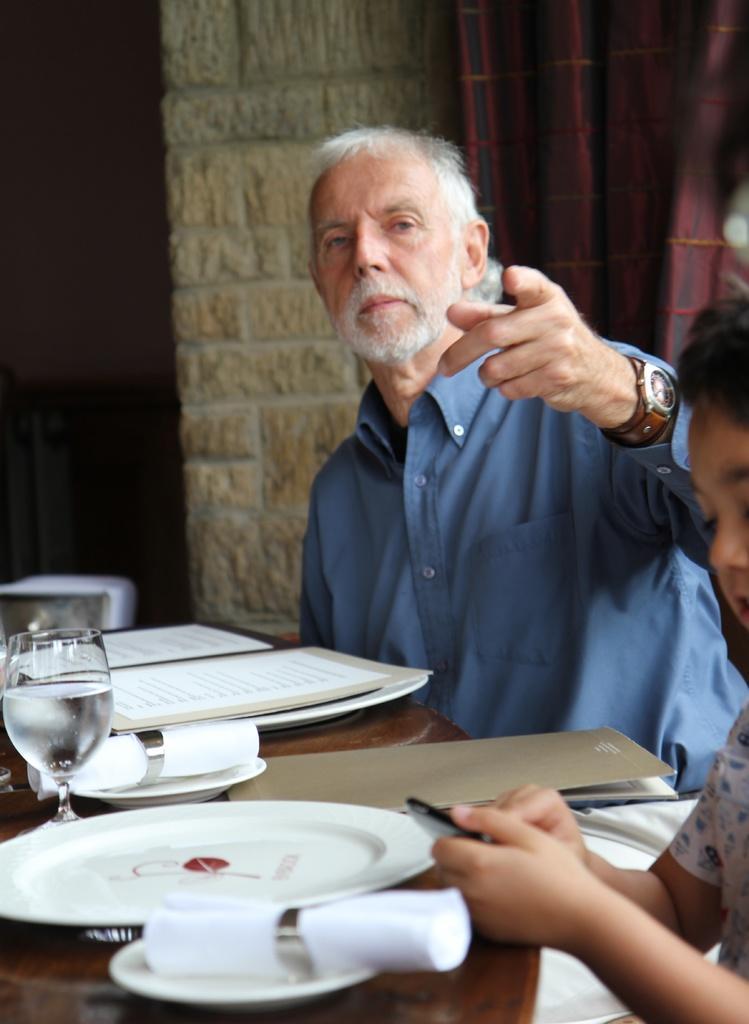How would you summarize this image in a sentence or two? In the center of the image we can see two persons are sitting. Among them, we can see one person is holding some object. In front of them, we can see one table. On the table, we can see books, papers, plates, one glass and a few other objects. In the background there is a wall, curtain and a few other objects. 